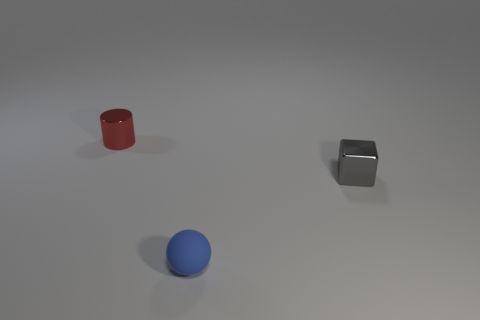Is the number of balls in front of the tiny red metallic object greater than the number of small blue objects that are on the right side of the gray shiny thing?
Your response must be concise. Yes. There is a small thing that is in front of the gray cube; what is its material?
Provide a succinct answer. Rubber. Is the shape of the blue object the same as the shiny object to the right of the small blue ball?
Ensure brevity in your answer.  No. There is a small metallic thing on the right side of the thing that is left of the small matte ball; what number of metallic cylinders are in front of it?
Your answer should be compact. 0. Is there any other thing that is the same shape as the tiny gray thing?
Your response must be concise. No. What number of cubes are tiny matte things or gray things?
Your answer should be compact. 1. The red shiny object has what shape?
Your response must be concise. Cylinder. There is a small blue matte object; are there any tiny metallic things on the left side of it?
Ensure brevity in your answer.  Yes. Is the material of the blue ball the same as the small thing on the right side of the tiny matte sphere?
Your answer should be compact. No. What number of other blocks are the same material as the cube?
Offer a very short reply. 0. 